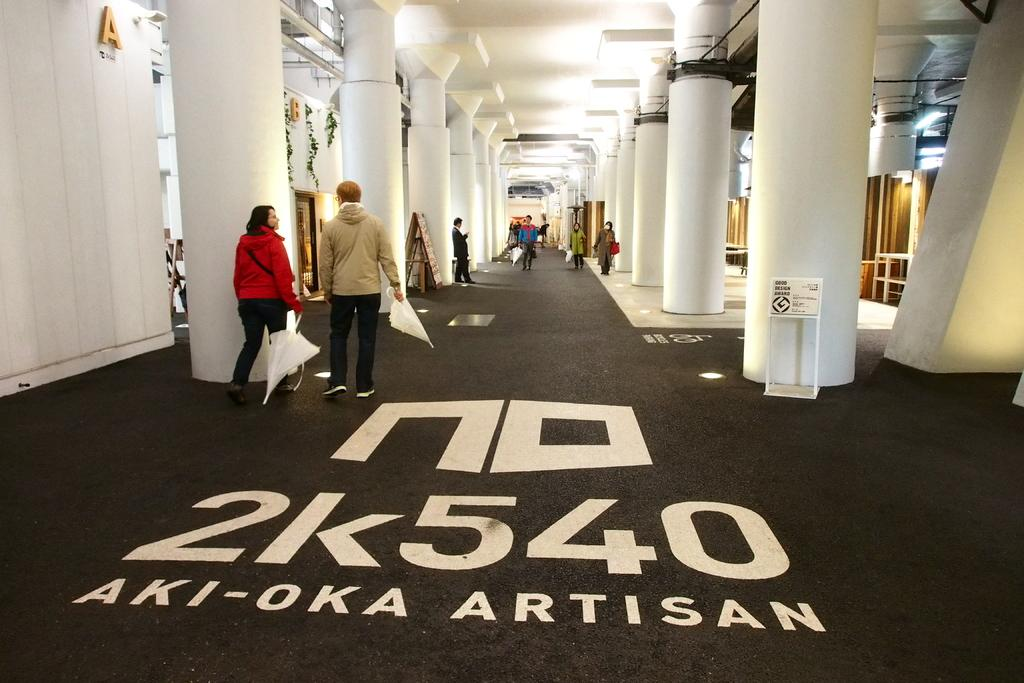What are the persons in the image doing? The persons in the image are on the floor and holding umbrellas. What architectural features can be seen in the image? There are pillars, boards, and a wall in the image. What type of sail can be seen on the cart in the image? There is no cart or sail present in the image. What is the name of the downtown area where the image was taken? The location of the image is not mentioned in the provided facts, so it cannot be determined if it is in a downtown area. 